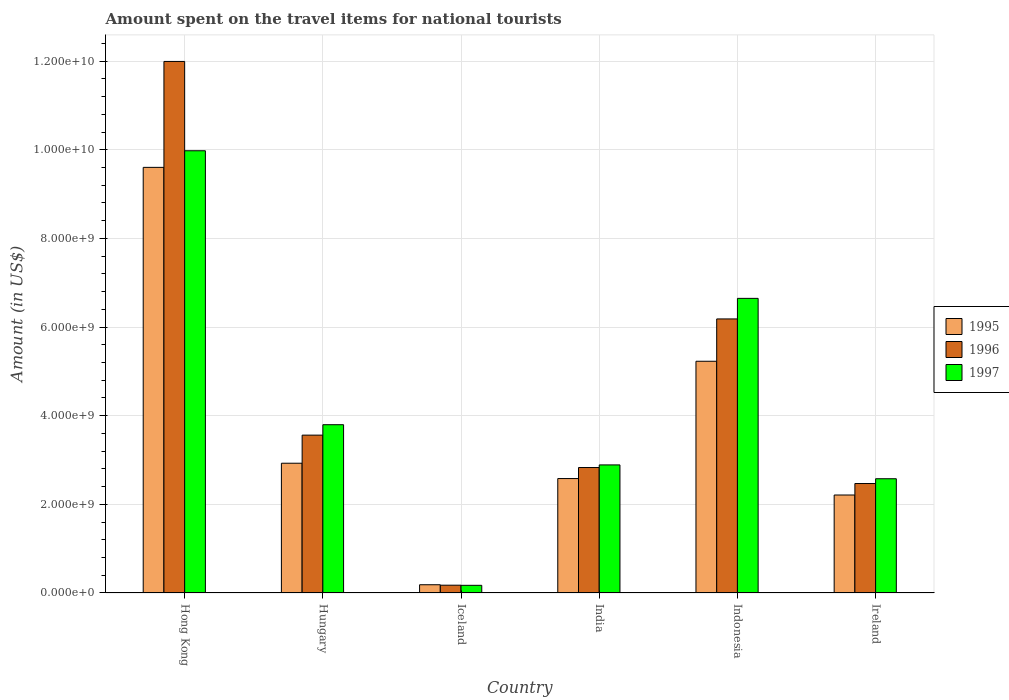Are the number of bars per tick equal to the number of legend labels?
Offer a terse response. Yes. How many bars are there on the 3rd tick from the left?
Make the answer very short. 3. How many bars are there on the 5th tick from the right?
Your answer should be compact. 3. What is the label of the 4th group of bars from the left?
Make the answer very short. India. In how many cases, is the number of bars for a given country not equal to the number of legend labels?
Your answer should be very brief. 0. What is the amount spent on the travel items for national tourists in 1995 in India?
Your answer should be very brief. 2.58e+09. Across all countries, what is the maximum amount spent on the travel items for national tourists in 1997?
Give a very brief answer. 9.98e+09. Across all countries, what is the minimum amount spent on the travel items for national tourists in 1996?
Your answer should be compact. 1.76e+08. In which country was the amount spent on the travel items for national tourists in 1997 maximum?
Keep it short and to the point. Hong Kong. In which country was the amount spent on the travel items for national tourists in 1997 minimum?
Make the answer very short. Iceland. What is the total amount spent on the travel items for national tourists in 1997 in the graph?
Your response must be concise. 2.61e+1. What is the difference between the amount spent on the travel items for national tourists in 1995 in Hong Kong and that in Iceland?
Keep it short and to the point. 9.42e+09. What is the difference between the amount spent on the travel items for national tourists in 1996 in Iceland and the amount spent on the travel items for national tourists in 1997 in Hong Kong?
Provide a short and direct response. -9.80e+09. What is the average amount spent on the travel items for national tourists in 1996 per country?
Offer a terse response. 4.54e+09. What is the difference between the amount spent on the travel items for national tourists of/in 1995 and amount spent on the travel items for national tourists of/in 1996 in India?
Make the answer very short. -2.49e+08. What is the ratio of the amount spent on the travel items for national tourists in 1996 in Hong Kong to that in Iceland?
Provide a short and direct response. 68.15. Is the amount spent on the travel items for national tourists in 1995 in Hong Kong less than that in Ireland?
Ensure brevity in your answer.  No. What is the difference between the highest and the second highest amount spent on the travel items for national tourists in 1996?
Your answer should be compact. 5.81e+09. What is the difference between the highest and the lowest amount spent on the travel items for national tourists in 1996?
Provide a short and direct response. 1.18e+1. Is the sum of the amount spent on the travel items for national tourists in 1995 in Hungary and Ireland greater than the maximum amount spent on the travel items for national tourists in 1997 across all countries?
Offer a terse response. No. What does the 2nd bar from the left in Ireland represents?
Make the answer very short. 1996. Is it the case that in every country, the sum of the amount spent on the travel items for national tourists in 1995 and amount spent on the travel items for national tourists in 1996 is greater than the amount spent on the travel items for national tourists in 1997?
Keep it short and to the point. Yes. Are all the bars in the graph horizontal?
Give a very brief answer. No. What is the difference between two consecutive major ticks on the Y-axis?
Your answer should be compact. 2.00e+09. Are the values on the major ticks of Y-axis written in scientific E-notation?
Provide a succinct answer. Yes. Does the graph contain any zero values?
Your answer should be very brief. No. Does the graph contain grids?
Offer a terse response. Yes. Where does the legend appear in the graph?
Offer a very short reply. Center right. What is the title of the graph?
Your answer should be very brief. Amount spent on the travel items for national tourists. What is the label or title of the X-axis?
Provide a short and direct response. Country. What is the label or title of the Y-axis?
Keep it short and to the point. Amount (in US$). What is the Amount (in US$) in 1995 in Hong Kong?
Make the answer very short. 9.60e+09. What is the Amount (in US$) in 1996 in Hong Kong?
Provide a succinct answer. 1.20e+1. What is the Amount (in US$) in 1997 in Hong Kong?
Your answer should be compact. 9.98e+09. What is the Amount (in US$) of 1995 in Hungary?
Your answer should be compact. 2.93e+09. What is the Amount (in US$) in 1996 in Hungary?
Offer a very short reply. 3.56e+09. What is the Amount (in US$) of 1997 in Hungary?
Keep it short and to the point. 3.80e+09. What is the Amount (in US$) in 1995 in Iceland?
Keep it short and to the point. 1.86e+08. What is the Amount (in US$) of 1996 in Iceland?
Keep it short and to the point. 1.76e+08. What is the Amount (in US$) of 1997 in Iceland?
Your response must be concise. 1.73e+08. What is the Amount (in US$) in 1995 in India?
Give a very brief answer. 2.58e+09. What is the Amount (in US$) in 1996 in India?
Offer a terse response. 2.83e+09. What is the Amount (in US$) of 1997 in India?
Ensure brevity in your answer.  2.89e+09. What is the Amount (in US$) of 1995 in Indonesia?
Your response must be concise. 5.23e+09. What is the Amount (in US$) of 1996 in Indonesia?
Your response must be concise. 6.18e+09. What is the Amount (in US$) in 1997 in Indonesia?
Provide a succinct answer. 6.65e+09. What is the Amount (in US$) of 1995 in Ireland?
Your response must be concise. 2.21e+09. What is the Amount (in US$) in 1996 in Ireland?
Make the answer very short. 2.47e+09. What is the Amount (in US$) in 1997 in Ireland?
Give a very brief answer. 2.58e+09. Across all countries, what is the maximum Amount (in US$) of 1995?
Make the answer very short. 9.60e+09. Across all countries, what is the maximum Amount (in US$) in 1996?
Keep it short and to the point. 1.20e+1. Across all countries, what is the maximum Amount (in US$) in 1997?
Your answer should be very brief. 9.98e+09. Across all countries, what is the minimum Amount (in US$) in 1995?
Provide a short and direct response. 1.86e+08. Across all countries, what is the minimum Amount (in US$) of 1996?
Your response must be concise. 1.76e+08. Across all countries, what is the minimum Amount (in US$) of 1997?
Provide a short and direct response. 1.73e+08. What is the total Amount (in US$) of 1995 in the graph?
Offer a terse response. 2.27e+1. What is the total Amount (in US$) in 1996 in the graph?
Provide a short and direct response. 2.72e+1. What is the total Amount (in US$) of 1997 in the graph?
Offer a very short reply. 2.61e+1. What is the difference between the Amount (in US$) in 1995 in Hong Kong and that in Hungary?
Offer a very short reply. 6.68e+09. What is the difference between the Amount (in US$) of 1996 in Hong Kong and that in Hungary?
Make the answer very short. 8.43e+09. What is the difference between the Amount (in US$) in 1997 in Hong Kong and that in Hungary?
Make the answer very short. 6.18e+09. What is the difference between the Amount (in US$) in 1995 in Hong Kong and that in Iceland?
Offer a terse response. 9.42e+09. What is the difference between the Amount (in US$) of 1996 in Hong Kong and that in Iceland?
Offer a terse response. 1.18e+1. What is the difference between the Amount (in US$) in 1997 in Hong Kong and that in Iceland?
Keep it short and to the point. 9.81e+09. What is the difference between the Amount (in US$) in 1995 in Hong Kong and that in India?
Give a very brief answer. 7.02e+09. What is the difference between the Amount (in US$) of 1996 in Hong Kong and that in India?
Make the answer very short. 9.16e+09. What is the difference between the Amount (in US$) of 1997 in Hong Kong and that in India?
Give a very brief answer. 7.09e+09. What is the difference between the Amount (in US$) in 1995 in Hong Kong and that in Indonesia?
Provide a succinct answer. 4.38e+09. What is the difference between the Amount (in US$) in 1996 in Hong Kong and that in Indonesia?
Offer a very short reply. 5.81e+09. What is the difference between the Amount (in US$) of 1997 in Hong Kong and that in Indonesia?
Ensure brevity in your answer.  3.33e+09. What is the difference between the Amount (in US$) in 1995 in Hong Kong and that in Ireland?
Provide a succinct answer. 7.39e+09. What is the difference between the Amount (in US$) in 1996 in Hong Kong and that in Ireland?
Give a very brief answer. 9.52e+09. What is the difference between the Amount (in US$) in 1997 in Hong Kong and that in Ireland?
Make the answer very short. 7.40e+09. What is the difference between the Amount (in US$) of 1995 in Hungary and that in Iceland?
Provide a succinct answer. 2.74e+09. What is the difference between the Amount (in US$) in 1996 in Hungary and that in Iceland?
Ensure brevity in your answer.  3.39e+09. What is the difference between the Amount (in US$) in 1997 in Hungary and that in Iceland?
Give a very brief answer. 3.62e+09. What is the difference between the Amount (in US$) of 1995 in Hungary and that in India?
Offer a very short reply. 3.46e+08. What is the difference between the Amount (in US$) in 1996 in Hungary and that in India?
Your answer should be very brief. 7.31e+08. What is the difference between the Amount (in US$) in 1997 in Hungary and that in India?
Make the answer very short. 9.07e+08. What is the difference between the Amount (in US$) of 1995 in Hungary and that in Indonesia?
Keep it short and to the point. -2.30e+09. What is the difference between the Amount (in US$) in 1996 in Hungary and that in Indonesia?
Ensure brevity in your answer.  -2.62e+09. What is the difference between the Amount (in US$) of 1997 in Hungary and that in Indonesia?
Offer a very short reply. -2.85e+09. What is the difference between the Amount (in US$) of 1995 in Hungary and that in Ireland?
Provide a short and direct response. 7.17e+08. What is the difference between the Amount (in US$) in 1996 in Hungary and that in Ireland?
Offer a very short reply. 1.09e+09. What is the difference between the Amount (in US$) in 1997 in Hungary and that in Ireland?
Provide a short and direct response. 1.22e+09. What is the difference between the Amount (in US$) of 1995 in Iceland and that in India?
Make the answer very short. -2.40e+09. What is the difference between the Amount (in US$) in 1996 in Iceland and that in India?
Provide a succinct answer. -2.66e+09. What is the difference between the Amount (in US$) in 1997 in Iceland and that in India?
Give a very brief answer. -2.72e+09. What is the difference between the Amount (in US$) of 1995 in Iceland and that in Indonesia?
Provide a short and direct response. -5.04e+09. What is the difference between the Amount (in US$) of 1996 in Iceland and that in Indonesia?
Make the answer very short. -6.01e+09. What is the difference between the Amount (in US$) in 1997 in Iceland and that in Indonesia?
Ensure brevity in your answer.  -6.48e+09. What is the difference between the Amount (in US$) in 1995 in Iceland and that in Ireland?
Your answer should be compact. -2.02e+09. What is the difference between the Amount (in US$) in 1996 in Iceland and that in Ireland?
Your answer should be very brief. -2.29e+09. What is the difference between the Amount (in US$) in 1997 in Iceland and that in Ireland?
Your answer should be compact. -2.40e+09. What is the difference between the Amount (in US$) of 1995 in India and that in Indonesia?
Provide a short and direct response. -2.65e+09. What is the difference between the Amount (in US$) in 1996 in India and that in Indonesia?
Your response must be concise. -3.35e+09. What is the difference between the Amount (in US$) in 1997 in India and that in Indonesia?
Ensure brevity in your answer.  -3.76e+09. What is the difference between the Amount (in US$) of 1995 in India and that in Ireland?
Ensure brevity in your answer.  3.71e+08. What is the difference between the Amount (in US$) in 1996 in India and that in Ireland?
Your answer should be very brief. 3.61e+08. What is the difference between the Amount (in US$) in 1997 in India and that in Ireland?
Your answer should be compact. 3.12e+08. What is the difference between the Amount (in US$) in 1995 in Indonesia and that in Ireland?
Ensure brevity in your answer.  3.02e+09. What is the difference between the Amount (in US$) of 1996 in Indonesia and that in Ireland?
Give a very brief answer. 3.71e+09. What is the difference between the Amount (in US$) of 1997 in Indonesia and that in Ireland?
Keep it short and to the point. 4.07e+09. What is the difference between the Amount (in US$) in 1995 in Hong Kong and the Amount (in US$) in 1996 in Hungary?
Your response must be concise. 6.04e+09. What is the difference between the Amount (in US$) of 1995 in Hong Kong and the Amount (in US$) of 1997 in Hungary?
Your answer should be compact. 5.81e+09. What is the difference between the Amount (in US$) of 1996 in Hong Kong and the Amount (in US$) of 1997 in Hungary?
Provide a succinct answer. 8.20e+09. What is the difference between the Amount (in US$) of 1995 in Hong Kong and the Amount (in US$) of 1996 in Iceland?
Ensure brevity in your answer.  9.43e+09. What is the difference between the Amount (in US$) in 1995 in Hong Kong and the Amount (in US$) in 1997 in Iceland?
Your response must be concise. 9.43e+09. What is the difference between the Amount (in US$) in 1996 in Hong Kong and the Amount (in US$) in 1997 in Iceland?
Provide a short and direct response. 1.18e+1. What is the difference between the Amount (in US$) of 1995 in Hong Kong and the Amount (in US$) of 1996 in India?
Your answer should be very brief. 6.77e+09. What is the difference between the Amount (in US$) in 1995 in Hong Kong and the Amount (in US$) in 1997 in India?
Provide a succinct answer. 6.71e+09. What is the difference between the Amount (in US$) in 1996 in Hong Kong and the Amount (in US$) in 1997 in India?
Keep it short and to the point. 9.10e+09. What is the difference between the Amount (in US$) of 1995 in Hong Kong and the Amount (in US$) of 1996 in Indonesia?
Ensure brevity in your answer.  3.42e+09. What is the difference between the Amount (in US$) of 1995 in Hong Kong and the Amount (in US$) of 1997 in Indonesia?
Your answer should be compact. 2.96e+09. What is the difference between the Amount (in US$) in 1996 in Hong Kong and the Amount (in US$) in 1997 in Indonesia?
Your answer should be compact. 5.35e+09. What is the difference between the Amount (in US$) in 1995 in Hong Kong and the Amount (in US$) in 1996 in Ireland?
Your answer should be compact. 7.13e+09. What is the difference between the Amount (in US$) in 1995 in Hong Kong and the Amount (in US$) in 1997 in Ireland?
Your response must be concise. 7.03e+09. What is the difference between the Amount (in US$) of 1996 in Hong Kong and the Amount (in US$) of 1997 in Ireland?
Your answer should be very brief. 9.42e+09. What is the difference between the Amount (in US$) of 1995 in Hungary and the Amount (in US$) of 1996 in Iceland?
Your answer should be very brief. 2.75e+09. What is the difference between the Amount (in US$) of 1995 in Hungary and the Amount (in US$) of 1997 in Iceland?
Your answer should be compact. 2.76e+09. What is the difference between the Amount (in US$) of 1996 in Hungary and the Amount (in US$) of 1997 in Iceland?
Keep it short and to the point. 3.39e+09. What is the difference between the Amount (in US$) of 1995 in Hungary and the Amount (in US$) of 1996 in India?
Offer a terse response. 9.70e+07. What is the difference between the Amount (in US$) in 1995 in Hungary and the Amount (in US$) in 1997 in India?
Give a very brief answer. 3.80e+07. What is the difference between the Amount (in US$) in 1996 in Hungary and the Amount (in US$) in 1997 in India?
Offer a very short reply. 6.72e+08. What is the difference between the Amount (in US$) of 1995 in Hungary and the Amount (in US$) of 1996 in Indonesia?
Your answer should be compact. -3.26e+09. What is the difference between the Amount (in US$) of 1995 in Hungary and the Amount (in US$) of 1997 in Indonesia?
Your response must be concise. -3.72e+09. What is the difference between the Amount (in US$) in 1996 in Hungary and the Amount (in US$) in 1997 in Indonesia?
Provide a short and direct response. -3.09e+09. What is the difference between the Amount (in US$) in 1995 in Hungary and the Amount (in US$) in 1996 in Ireland?
Ensure brevity in your answer.  4.58e+08. What is the difference between the Amount (in US$) in 1995 in Hungary and the Amount (in US$) in 1997 in Ireland?
Make the answer very short. 3.50e+08. What is the difference between the Amount (in US$) in 1996 in Hungary and the Amount (in US$) in 1997 in Ireland?
Ensure brevity in your answer.  9.84e+08. What is the difference between the Amount (in US$) in 1995 in Iceland and the Amount (in US$) in 1996 in India?
Your response must be concise. -2.64e+09. What is the difference between the Amount (in US$) in 1995 in Iceland and the Amount (in US$) in 1997 in India?
Your answer should be very brief. -2.70e+09. What is the difference between the Amount (in US$) of 1996 in Iceland and the Amount (in US$) of 1997 in India?
Ensure brevity in your answer.  -2.71e+09. What is the difference between the Amount (in US$) in 1995 in Iceland and the Amount (in US$) in 1996 in Indonesia?
Your answer should be compact. -6.00e+09. What is the difference between the Amount (in US$) in 1995 in Iceland and the Amount (in US$) in 1997 in Indonesia?
Offer a terse response. -6.46e+09. What is the difference between the Amount (in US$) of 1996 in Iceland and the Amount (in US$) of 1997 in Indonesia?
Provide a short and direct response. -6.47e+09. What is the difference between the Amount (in US$) of 1995 in Iceland and the Amount (in US$) of 1996 in Ireland?
Your answer should be very brief. -2.28e+09. What is the difference between the Amount (in US$) in 1995 in Iceland and the Amount (in US$) in 1997 in Ireland?
Provide a succinct answer. -2.39e+09. What is the difference between the Amount (in US$) in 1996 in Iceland and the Amount (in US$) in 1997 in Ireland?
Offer a terse response. -2.40e+09. What is the difference between the Amount (in US$) of 1995 in India and the Amount (in US$) of 1996 in Indonesia?
Provide a short and direct response. -3.60e+09. What is the difference between the Amount (in US$) of 1995 in India and the Amount (in US$) of 1997 in Indonesia?
Your answer should be very brief. -4.07e+09. What is the difference between the Amount (in US$) of 1996 in India and the Amount (in US$) of 1997 in Indonesia?
Make the answer very short. -3.82e+09. What is the difference between the Amount (in US$) in 1995 in India and the Amount (in US$) in 1996 in Ireland?
Keep it short and to the point. 1.12e+08. What is the difference between the Amount (in US$) in 1996 in India and the Amount (in US$) in 1997 in Ireland?
Make the answer very short. 2.53e+08. What is the difference between the Amount (in US$) of 1995 in Indonesia and the Amount (in US$) of 1996 in Ireland?
Provide a succinct answer. 2.76e+09. What is the difference between the Amount (in US$) in 1995 in Indonesia and the Amount (in US$) in 1997 in Ireland?
Offer a terse response. 2.65e+09. What is the difference between the Amount (in US$) in 1996 in Indonesia and the Amount (in US$) in 1997 in Ireland?
Offer a very short reply. 3.61e+09. What is the average Amount (in US$) of 1995 per country?
Ensure brevity in your answer.  3.79e+09. What is the average Amount (in US$) of 1996 per country?
Offer a terse response. 4.54e+09. What is the average Amount (in US$) in 1997 per country?
Keep it short and to the point. 4.34e+09. What is the difference between the Amount (in US$) in 1995 and Amount (in US$) in 1996 in Hong Kong?
Offer a very short reply. -2.39e+09. What is the difference between the Amount (in US$) of 1995 and Amount (in US$) of 1997 in Hong Kong?
Your answer should be compact. -3.75e+08. What is the difference between the Amount (in US$) of 1996 and Amount (in US$) of 1997 in Hong Kong?
Offer a very short reply. 2.02e+09. What is the difference between the Amount (in US$) of 1995 and Amount (in US$) of 1996 in Hungary?
Your response must be concise. -6.34e+08. What is the difference between the Amount (in US$) in 1995 and Amount (in US$) in 1997 in Hungary?
Offer a very short reply. -8.69e+08. What is the difference between the Amount (in US$) in 1996 and Amount (in US$) in 1997 in Hungary?
Ensure brevity in your answer.  -2.35e+08. What is the difference between the Amount (in US$) in 1995 and Amount (in US$) in 1996 in Iceland?
Your response must be concise. 1.00e+07. What is the difference between the Amount (in US$) of 1995 and Amount (in US$) of 1997 in Iceland?
Offer a terse response. 1.30e+07. What is the difference between the Amount (in US$) in 1996 and Amount (in US$) in 1997 in Iceland?
Offer a terse response. 3.00e+06. What is the difference between the Amount (in US$) in 1995 and Amount (in US$) in 1996 in India?
Ensure brevity in your answer.  -2.49e+08. What is the difference between the Amount (in US$) in 1995 and Amount (in US$) in 1997 in India?
Give a very brief answer. -3.08e+08. What is the difference between the Amount (in US$) in 1996 and Amount (in US$) in 1997 in India?
Offer a terse response. -5.90e+07. What is the difference between the Amount (in US$) in 1995 and Amount (in US$) in 1996 in Indonesia?
Your answer should be compact. -9.55e+08. What is the difference between the Amount (in US$) in 1995 and Amount (in US$) in 1997 in Indonesia?
Keep it short and to the point. -1.42e+09. What is the difference between the Amount (in US$) in 1996 and Amount (in US$) in 1997 in Indonesia?
Your answer should be compact. -4.64e+08. What is the difference between the Amount (in US$) in 1995 and Amount (in US$) in 1996 in Ireland?
Your answer should be very brief. -2.59e+08. What is the difference between the Amount (in US$) of 1995 and Amount (in US$) of 1997 in Ireland?
Your answer should be compact. -3.67e+08. What is the difference between the Amount (in US$) of 1996 and Amount (in US$) of 1997 in Ireland?
Ensure brevity in your answer.  -1.08e+08. What is the ratio of the Amount (in US$) of 1995 in Hong Kong to that in Hungary?
Keep it short and to the point. 3.28. What is the ratio of the Amount (in US$) in 1996 in Hong Kong to that in Hungary?
Offer a terse response. 3.37. What is the ratio of the Amount (in US$) in 1997 in Hong Kong to that in Hungary?
Make the answer very short. 2.63. What is the ratio of the Amount (in US$) of 1995 in Hong Kong to that in Iceland?
Your answer should be very brief. 51.63. What is the ratio of the Amount (in US$) in 1996 in Hong Kong to that in Iceland?
Your answer should be very brief. 68.15. What is the ratio of the Amount (in US$) in 1997 in Hong Kong to that in Iceland?
Ensure brevity in your answer.  57.68. What is the ratio of the Amount (in US$) in 1995 in Hong Kong to that in India?
Make the answer very short. 3.72. What is the ratio of the Amount (in US$) in 1996 in Hong Kong to that in India?
Make the answer very short. 4.24. What is the ratio of the Amount (in US$) in 1997 in Hong Kong to that in India?
Your answer should be very brief. 3.45. What is the ratio of the Amount (in US$) in 1995 in Hong Kong to that in Indonesia?
Keep it short and to the point. 1.84. What is the ratio of the Amount (in US$) in 1996 in Hong Kong to that in Indonesia?
Keep it short and to the point. 1.94. What is the ratio of the Amount (in US$) of 1997 in Hong Kong to that in Indonesia?
Give a very brief answer. 1.5. What is the ratio of the Amount (in US$) in 1995 in Hong Kong to that in Ireland?
Your answer should be very brief. 4.34. What is the ratio of the Amount (in US$) of 1996 in Hong Kong to that in Ireland?
Your answer should be very brief. 4.86. What is the ratio of the Amount (in US$) in 1997 in Hong Kong to that in Ireland?
Provide a succinct answer. 3.87. What is the ratio of the Amount (in US$) of 1995 in Hungary to that in Iceland?
Keep it short and to the point. 15.74. What is the ratio of the Amount (in US$) in 1996 in Hungary to that in Iceland?
Ensure brevity in your answer.  20.24. What is the ratio of the Amount (in US$) in 1997 in Hungary to that in Iceland?
Your answer should be compact. 21.95. What is the ratio of the Amount (in US$) in 1995 in Hungary to that in India?
Keep it short and to the point. 1.13. What is the ratio of the Amount (in US$) of 1996 in Hungary to that in India?
Provide a short and direct response. 1.26. What is the ratio of the Amount (in US$) of 1997 in Hungary to that in India?
Provide a succinct answer. 1.31. What is the ratio of the Amount (in US$) in 1995 in Hungary to that in Indonesia?
Make the answer very short. 0.56. What is the ratio of the Amount (in US$) in 1996 in Hungary to that in Indonesia?
Your response must be concise. 0.58. What is the ratio of the Amount (in US$) of 1997 in Hungary to that in Indonesia?
Your answer should be compact. 0.57. What is the ratio of the Amount (in US$) of 1995 in Hungary to that in Ireland?
Make the answer very short. 1.32. What is the ratio of the Amount (in US$) in 1996 in Hungary to that in Ireland?
Provide a succinct answer. 1.44. What is the ratio of the Amount (in US$) of 1997 in Hungary to that in Ireland?
Give a very brief answer. 1.47. What is the ratio of the Amount (in US$) of 1995 in Iceland to that in India?
Your response must be concise. 0.07. What is the ratio of the Amount (in US$) in 1996 in Iceland to that in India?
Give a very brief answer. 0.06. What is the ratio of the Amount (in US$) in 1997 in Iceland to that in India?
Your response must be concise. 0.06. What is the ratio of the Amount (in US$) in 1995 in Iceland to that in Indonesia?
Offer a terse response. 0.04. What is the ratio of the Amount (in US$) of 1996 in Iceland to that in Indonesia?
Provide a succinct answer. 0.03. What is the ratio of the Amount (in US$) in 1997 in Iceland to that in Indonesia?
Your answer should be very brief. 0.03. What is the ratio of the Amount (in US$) in 1995 in Iceland to that in Ireland?
Your response must be concise. 0.08. What is the ratio of the Amount (in US$) of 1996 in Iceland to that in Ireland?
Your answer should be compact. 0.07. What is the ratio of the Amount (in US$) of 1997 in Iceland to that in Ireland?
Give a very brief answer. 0.07. What is the ratio of the Amount (in US$) in 1995 in India to that in Indonesia?
Ensure brevity in your answer.  0.49. What is the ratio of the Amount (in US$) in 1996 in India to that in Indonesia?
Offer a very short reply. 0.46. What is the ratio of the Amount (in US$) in 1997 in India to that in Indonesia?
Your response must be concise. 0.43. What is the ratio of the Amount (in US$) in 1995 in India to that in Ireland?
Provide a short and direct response. 1.17. What is the ratio of the Amount (in US$) of 1996 in India to that in Ireland?
Provide a succinct answer. 1.15. What is the ratio of the Amount (in US$) of 1997 in India to that in Ireland?
Offer a very short reply. 1.12. What is the ratio of the Amount (in US$) of 1995 in Indonesia to that in Ireland?
Ensure brevity in your answer.  2.37. What is the ratio of the Amount (in US$) of 1996 in Indonesia to that in Ireland?
Provide a short and direct response. 2.5. What is the ratio of the Amount (in US$) of 1997 in Indonesia to that in Ireland?
Your answer should be compact. 2.58. What is the difference between the highest and the second highest Amount (in US$) of 1995?
Give a very brief answer. 4.38e+09. What is the difference between the highest and the second highest Amount (in US$) of 1996?
Your answer should be very brief. 5.81e+09. What is the difference between the highest and the second highest Amount (in US$) of 1997?
Make the answer very short. 3.33e+09. What is the difference between the highest and the lowest Amount (in US$) of 1995?
Give a very brief answer. 9.42e+09. What is the difference between the highest and the lowest Amount (in US$) of 1996?
Offer a very short reply. 1.18e+1. What is the difference between the highest and the lowest Amount (in US$) in 1997?
Give a very brief answer. 9.81e+09. 